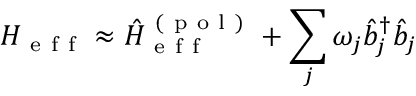<formula> <loc_0><loc_0><loc_500><loc_500>H _ { e f f } \approx \hat { H } _ { e f f } ^ { ( p o l ) } + \sum _ { j } \omega _ { j } \hat { b } _ { j } ^ { \dagger } \hat { b } _ { j }</formula> 